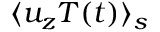Convert formula to latex. <formula><loc_0><loc_0><loc_500><loc_500>\langle u _ { z } T ( t ) \rangle _ { s }</formula> 